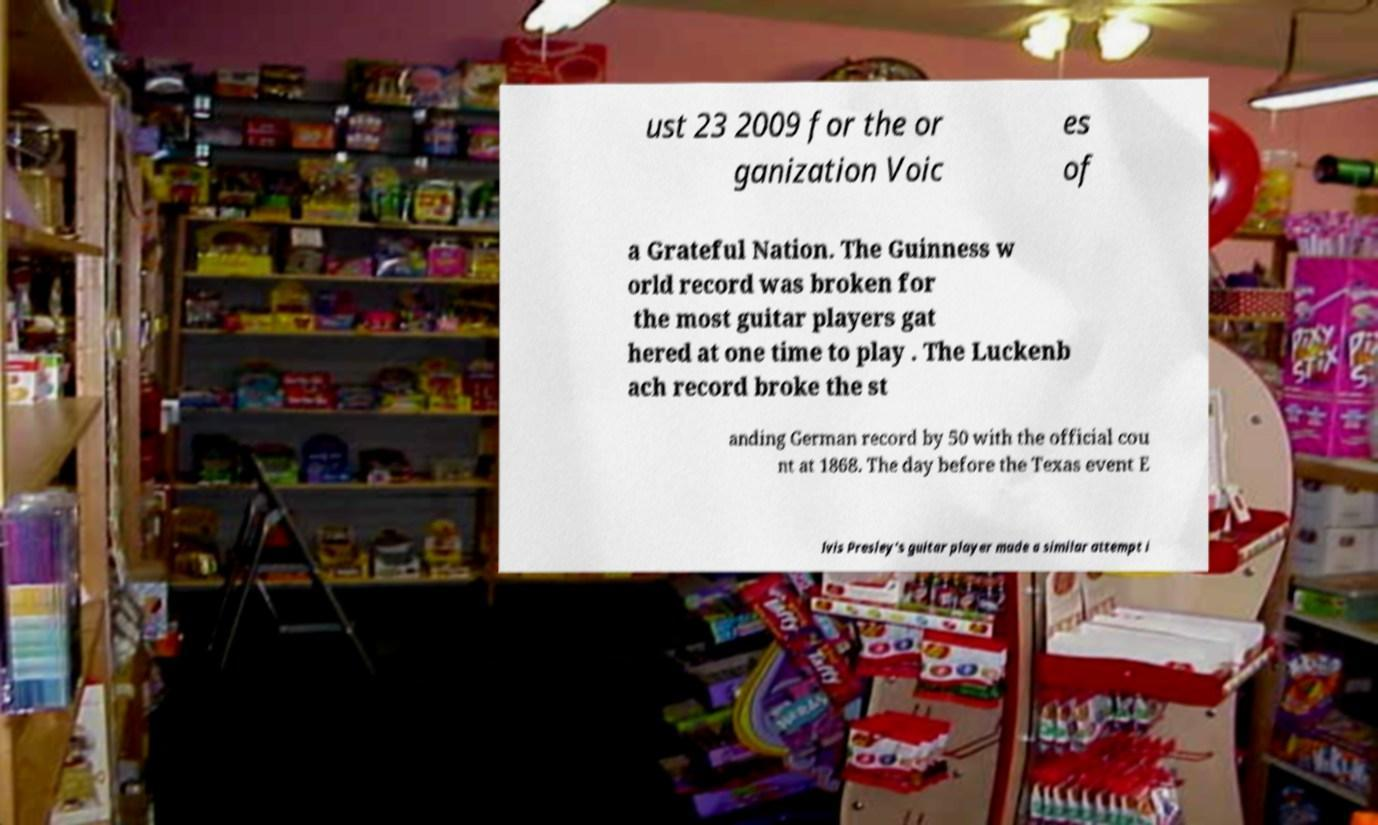There's text embedded in this image that I need extracted. Can you transcribe it verbatim? ust 23 2009 for the or ganization Voic es of a Grateful Nation. The Guinness w orld record was broken for the most guitar players gat hered at one time to play . The Luckenb ach record broke the st anding German record by 50 with the official cou nt at 1868. The day before the Texas event E lvis Presley’s guitar player made a similar attempt i 